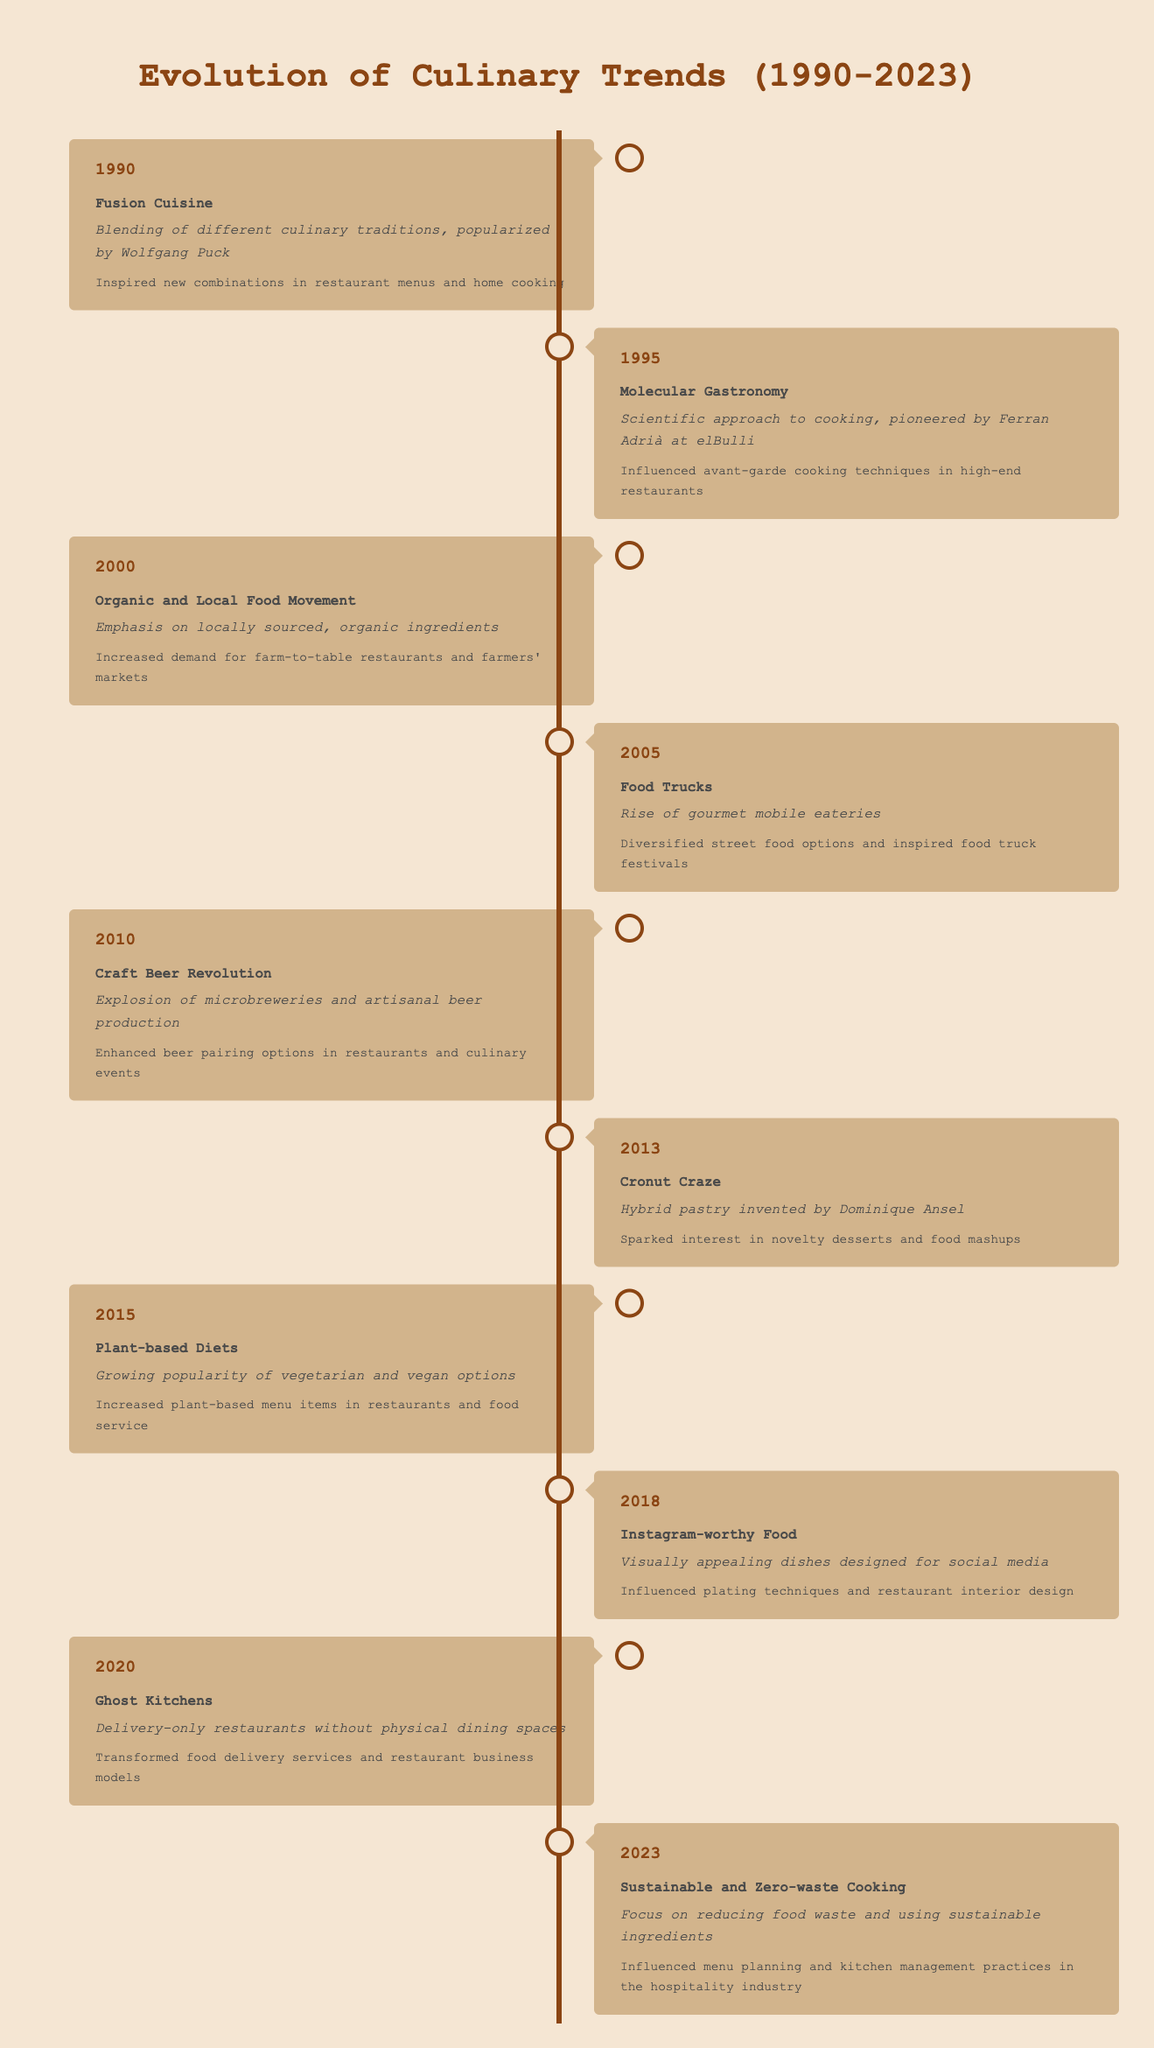What culinary trend was introduced in 1990? The trend introduced in 1990 is Fusion Cuisine, which is the blending of different culinary traditions and was popularized by Wolfgang Puck.
Answer: Fusion Cuisine Which trend emphasized locally sourced ingredients and was prominent in 2000? The trend that emphasized locally sourced ingredients in 2000 is the Organic and Local Food Movement, which focused on using organic ingredients from local sources.
Answer: Organic and Local Food Movement Is Molecular Gastronomy associated with high-end restaurants? Yes, Molecular Gastronomy, pioneered by Ferran Adrià, influenced avant-garde cooking techniques specifically in high-end restaurants.
Answer: Yes What impact did the Craft Beer Revolution have on restaurants in 2010? The Craft Beer Revolution enhanced beer pairing options in restaurants and culinary events, allowing for a variety of artisanal beer selections to accompany meals.
Answer: Enhanced beer pairing options How many years elapsed between the introduction of Food Trucks and Plant-based Diets? Food Trucks were introduced in 2005, and Plant-based Diets became popular in 2015. The difference is 10 years (2015 - 2005 = 10).
Answer: 10 years Which trend in 2018 focused on visually appealing dishes and social media? The trend in 2018 that focused on visually appealing dishes designed for social media is Instagram-worthy Food.
Answer: Instagram-worthy Food Did the trend of Ghost Kitchens appear before 2020? No, the trend of Ghost Kitchens emerged in 2020, which means it did not appear before that year.
Answer: No What is the significance of the Cronut Craze in 2013? The Cronut Craze, introduced by Dominique Ansel, sparked interest in novelty desserts and food mashups, influencing dessert culture.
Answer: Sparked interest in novelty desserts What was the primary focus of Sustainable and Zero-waste Cooking in 2023? The primary focus of Sustainable and Zero-waste Cooking in 2023 is to reduce food waste and use sustainable ingredients in culinary practices.
Answer: Reduce food waste and use sustainable ingredients 